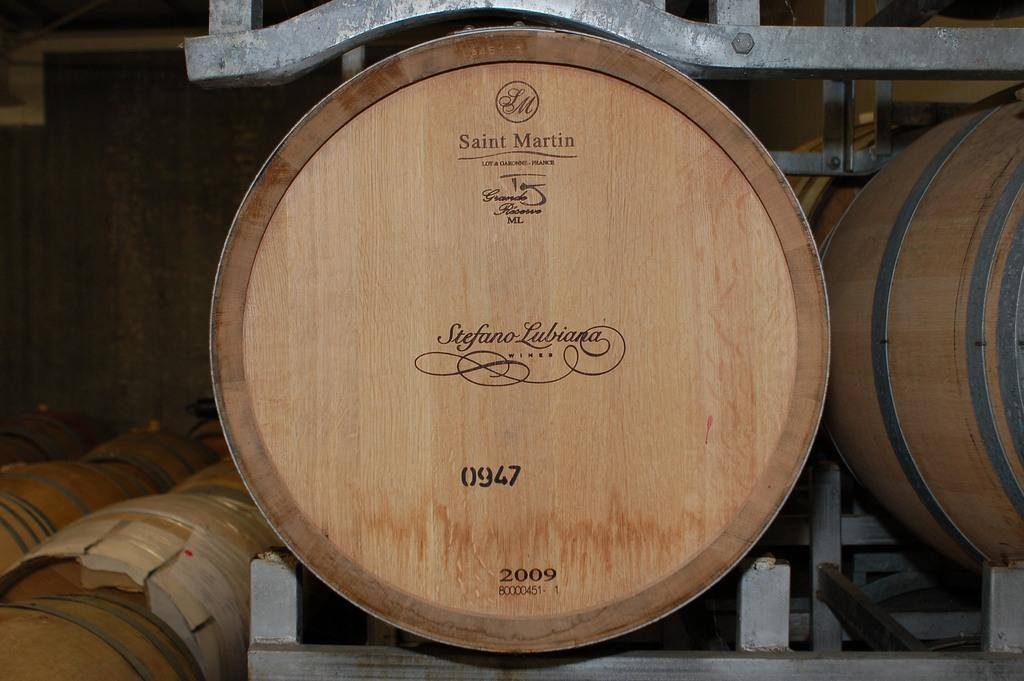What type of containers are in the image? There are wooden barrels in the image. How are the wooden barrels arranged or supported? The wooden barrels are on a steel rack. What can be seen in the background of the image? There is a wall visible in the background of the image. What type of silk can be seen hanging from the tree in the image? There is no silk or tree present in the image; it only features wooden barrels on a steel rack and a wall in the background. 